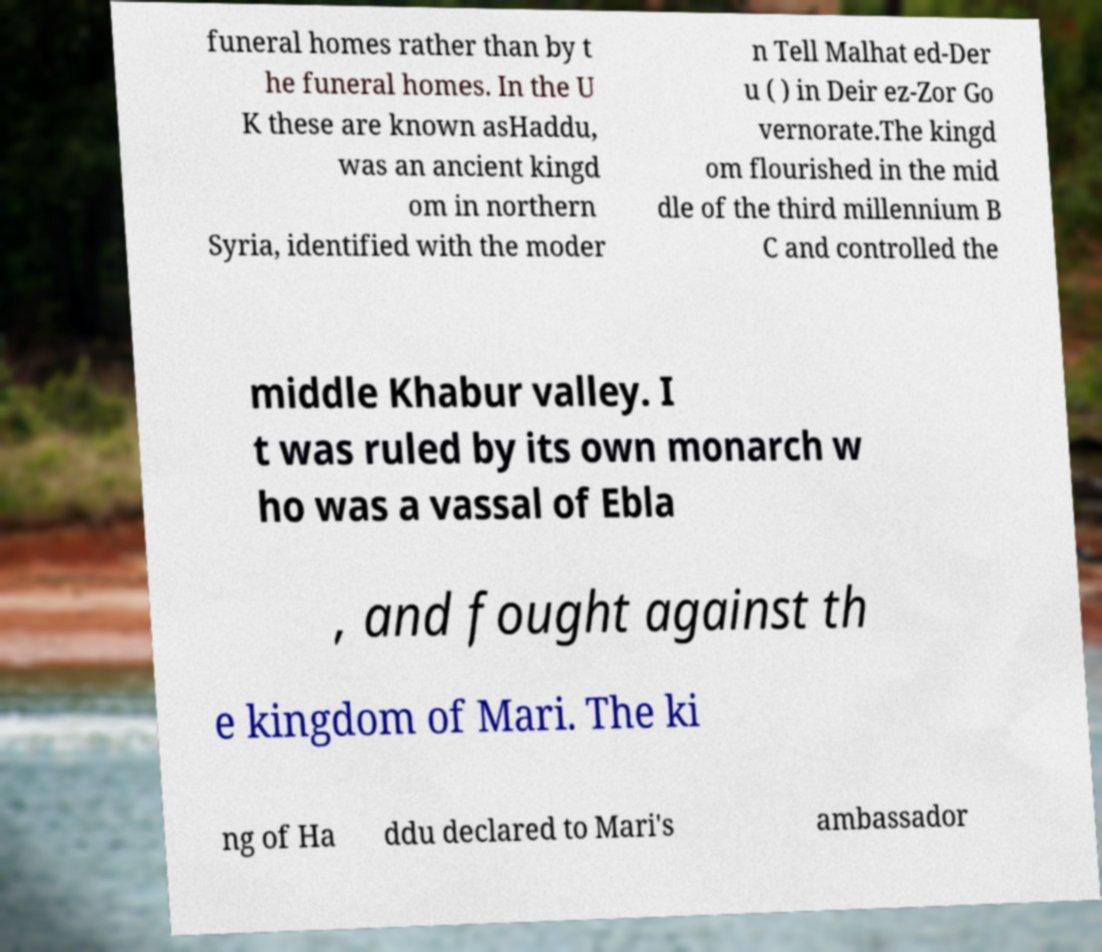Please read and relay the text visible in this image. What does it say? funeral homes rather than by t he funeral homes. In the U K these are known asHaddu, was an ancient kingd om in northern Syria, identified with the moder n Tell Malhat ed-Der u ( ) in Deir ez-Zor Go vernorate.The kingd om flourished in the mid dle of the third millennium B C and controlled the middle Khabur valley. I t was ruled by its own monarch w ho was a vassal of Ebla , and fought against th e kingdom of Mari. The ki ng of Ha ddu declared to Mari's ambassador 